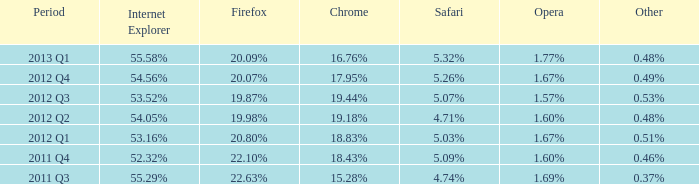Which other option has a 20.80% share similar to firefox? 0.51%. 